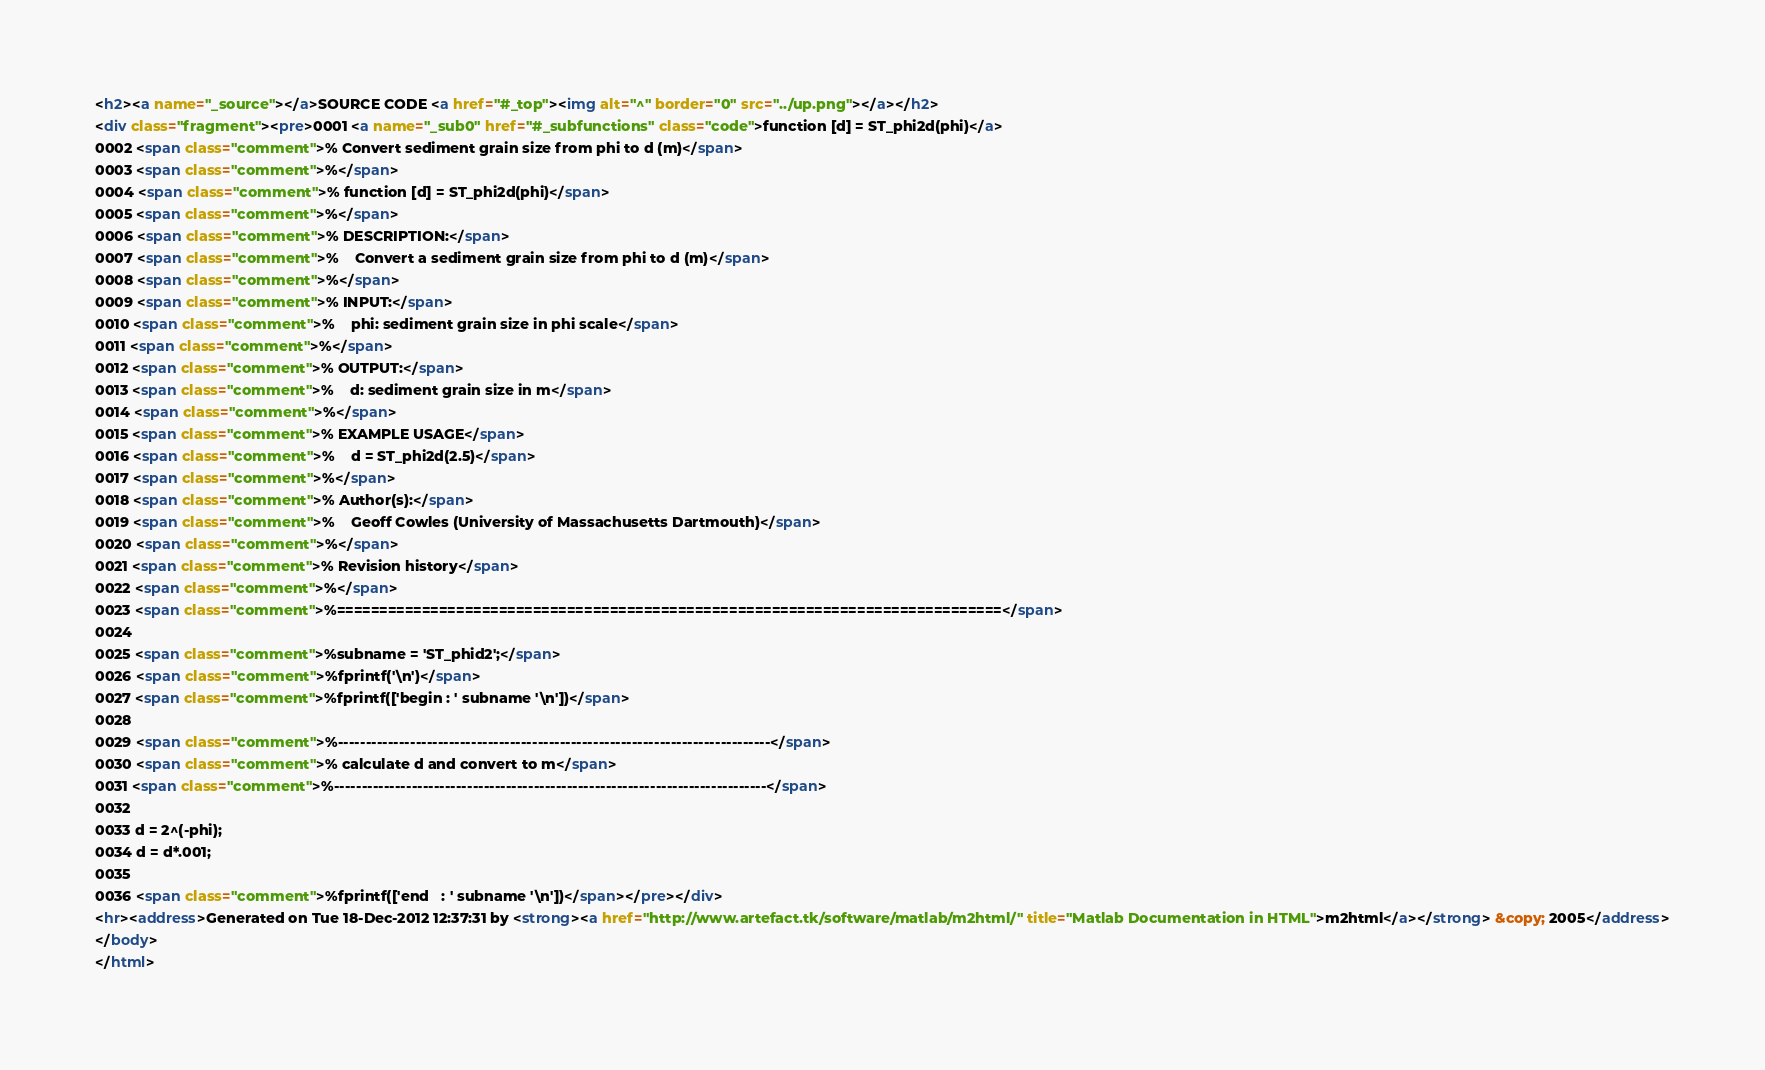Convert code to text. <code><loc_0><loc_0><loc_500><loc_500><_HTML_><h2><a name="_source"></a>SOURCE CODE <a href="#_top"><img alt="^" border="0" src="../up.png"></a></h2>
<div class="fragment"><pre>0001 <a name="_sub0" href="#_subfunctions" class="code">function [d] = ST_phi2d(phi)</a>
0002 <span class="comment">% Convert sediment grain size from phi to d (m)</span>
0003 <span class="comment">%</span>
0004 <span class="comment">% function [d] = ST_phi2d(phi)</span>
0005 <span class="comment">%</span>
0006 <span class="comment">% DESCRIPTION:</span>
0007 <span class="comment">%    Convert a sediment grain size from phi to d (m)</span>
0008 <span class="comment">%</span>
0009 <span class="comment">% INPUT:</span>
0010 <span class="comment">%    phi: sediment grain size in phi scale</span>
0011 <span class="comment">%</span>
0012 <span class="comment">% OUTPUT:</span>
0013 <span class="comment">%    d: sediment grain size in m</span>
0014 <span class="comment">%</span>
0015 <span class="comment">% EXAMPLE USAGE</span>
0016 <span class="comment">%    d = ST_phi2d(2.5)</span>
0017 <span class="comment">%</span>
0018 <span class="comment">% Author(s):</span>
0019 <span class="comment">%    Geoff Cowles (University of Massachusetts Dartmouth)</span>
0020 <span class="comment">%</span>
0021 <span class="comment">% Revision history</span>
0022 <span class="comment">%</span>
0023 <span class="comment">%==============================================================================</span>
0024 
0025 <span class="comment">%subname = 'ST_phid2';</span>
0026 <span class="comment">%fprintf('\n')</span>
0027 <span class="comment">%fprintf(['begin : ' subname '\n'])</span>
0028 
0029 <span class="comment">%------------------------------------------------------------------------------</span>
0030 <span class="comment">% calculate d and convert to m</span>
0031 <span class="comment">%------------------------------------------------------------------------------</span>
0032 
0033 d = 2^(-phi);
0034 d = d*.001;
0035 
0036 <span class="comment">%fprintf(['end   : ' subname '\n'])</span></pre></div>
<hr><address>Generated on Tue 18-Dec-2012 12:37:31 by <strong><a href="http://www.artefact.tk/software/matlab/m2html/" title="Matlab Documentation in HTML">m2html</a></strong> &copy; 2005</address>
</body>
</html></code> 